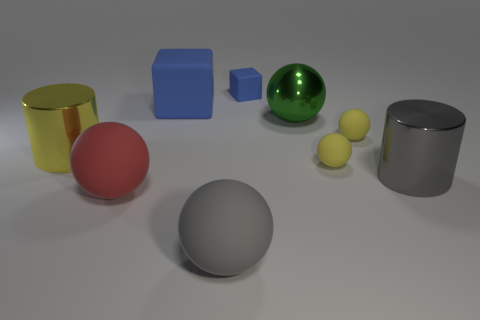The gray thing that is the same material as the big blue block is what size?
Keep it short and to the point. Large. Is the number of tiny blue cylinders less than the number of big yellow cylinders?
Offer a very short reply. Yes. The small yellow object that is behind the yellow matte object that is in front of the large cylinder left of the large blue object is made of what material?
Make the answer very short. Rubber. Is the material of the large gray thing that is left of the small block the same as the cube that is behind the large cube?
Offer a terse response. Yes. What is the size of the metal thing that is to the right of the large red ball and behind the gray shiny thing?
Provide a succinct answer. Large. There is a blue object that is the same size as the shiny ball; what is it made of?
Provide a short and direct response. Rubber. There is a object that is on the left side of the large ball left of the large gray ball; what number of big objects are in front of it?
Provide a succinct answer. 3. There is a tiny rubber thing behind the big green shiny ball; is its color the same as the large metal cylinder in front of the big yellow metal cylinder?
Ensure brevity in your answer.  No. What is the color of the large thing that is both right of the big gray matte sphere and on the left side of the big gray cylinder?
Offer a very short reply. Green. What number of brown metal cylinders have the same size as the red sphere?
Make the answer very short. 0. 